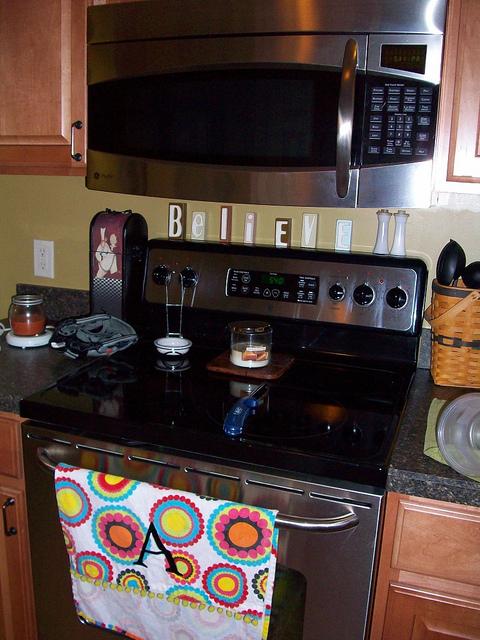Is there anything cooking on the stove?
Write a very short answer. No. What is the letter on the dishtowel?
Be succinct. A. What is above the stove?
Short answer required. Microwave. Is this stove on or off?
Be succinct. Off. 